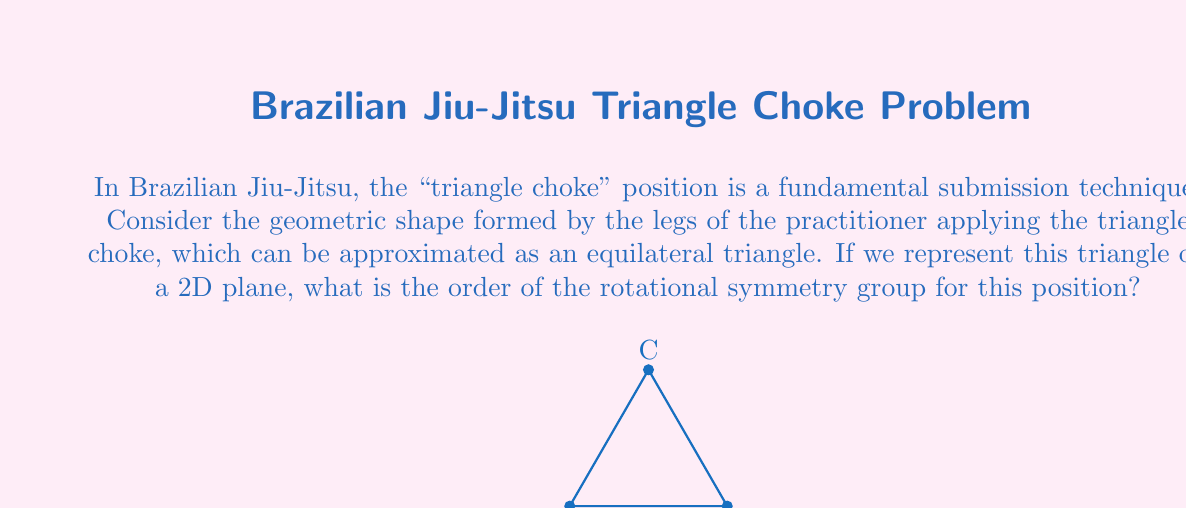Could you help me with this problem? To determine the order of the rotational symmetry group for the triangle choke position, we need to follow these steps:

1) First, recall that the order of a rotational symmetry group is the number of distinct rotations (including the identity rotation) that leave the shape unchanged.

2) For an equilateral triangle:
   - It has 3 vertices (A, B, C)
   - It has 3 equal sides
   - All internal angles are 60°

3) The possible rotations that leave the triangle unchanged are:
   - 0° rotation (identity): $$R_0$$
   - 120° rotation clockwise: $$R_{120}$$
   - 240° rotation clockwise: $$R_{240}$$ (equivalent to 120° counterclockwise)

4) We can verify that:
   $$R_0 \circ R_0 = R_0$$
   $$R_{120} \circ R_{120} = R_{240}$$
   $$R_{240} \circ R_{240} = R_{120}$$
   $$R_{120} \circ R_{240} = R_0$$

5) These rotations form a cyclic group of order 3, often denoted as $$C_3$$ or $$\mathbb{Z}_3$$.

6) Therefore, the order of the rotational symmetry group for the triangle choke position is 3.
Answer: 3 